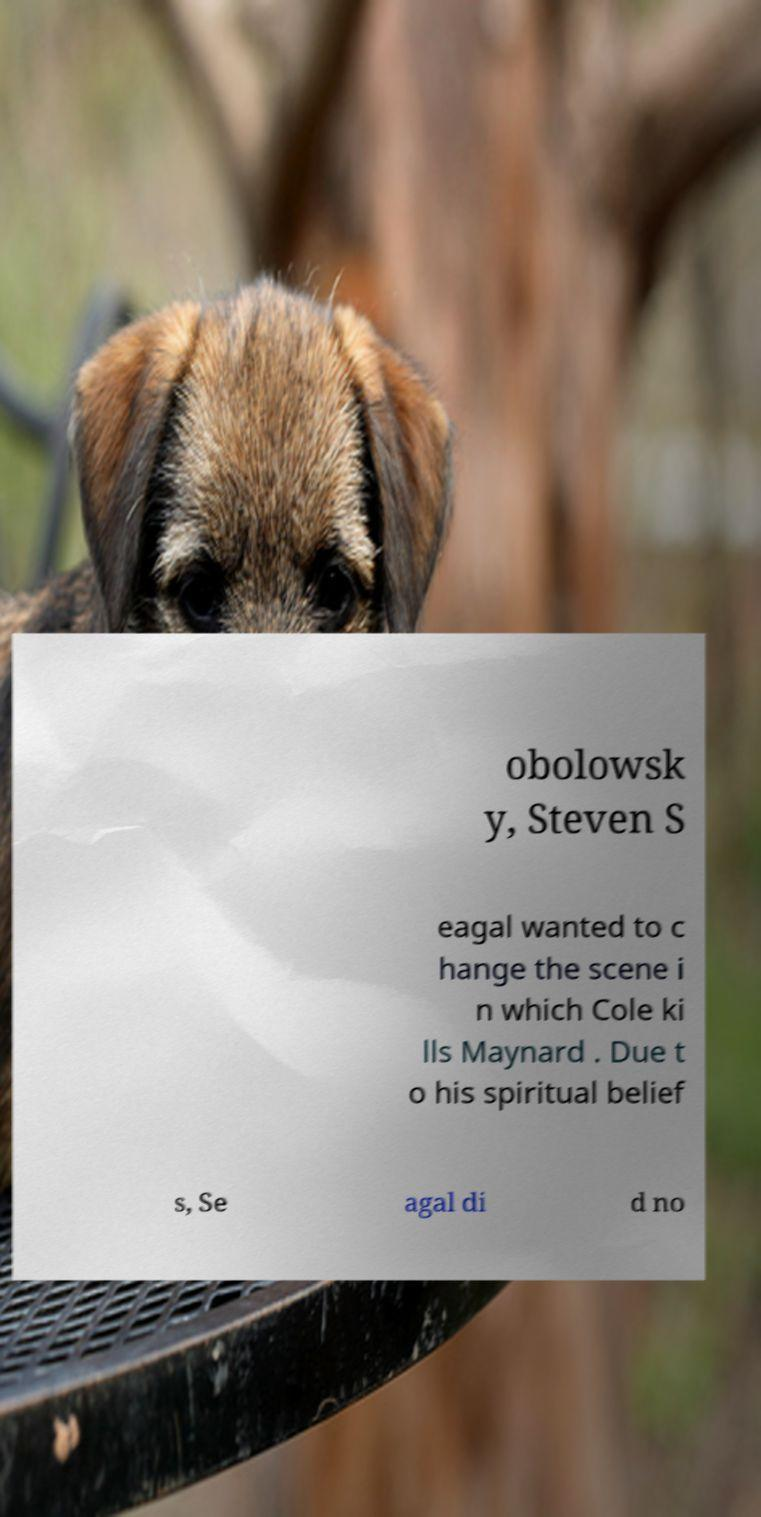For documentation purposes, I need the text within this image transcribed. Could you provide that? obolowsk y, Steven S eagal wanted to c hange the scene i n which Cole ki lls Maynard . Due t o his spiritual belief s, Se agal di d no 